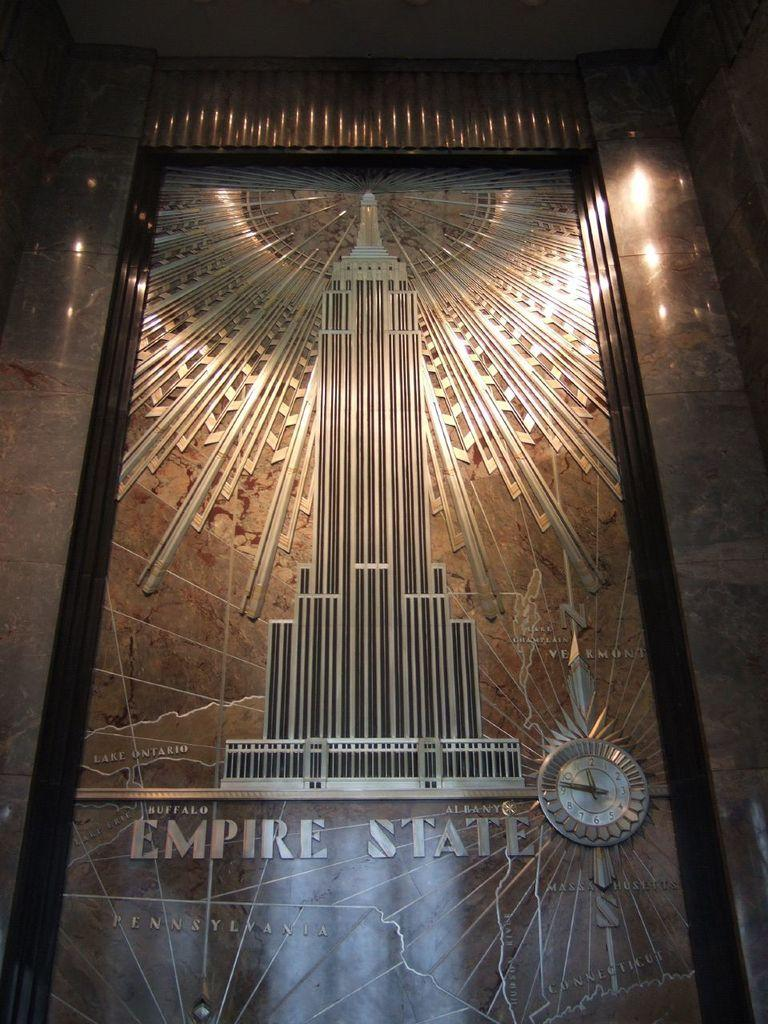<image>
Write a terse but informative summary of the picture. Albany Empire state with the building in a picture frame on the wall. 